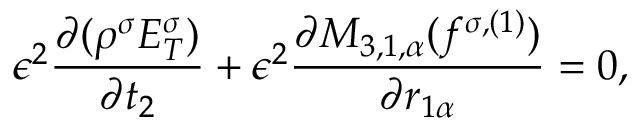<formula> <loc_0><loc_0><loc_500><loc_500>\epsilon ^ { 2 } \frac { \partial ( \rho ^ { \sigma } E _ { T } ^ { \sigma } ) } { \partial t _ { 2 } } + \epsilon ^ { 2 } \frac { \partial M _ { 3 , 1 , \alpha } ( f ^ { \sigma , ( 1 ) } ) } { \partial r _ { 1 \alpha } } = 0 ,</formula> 